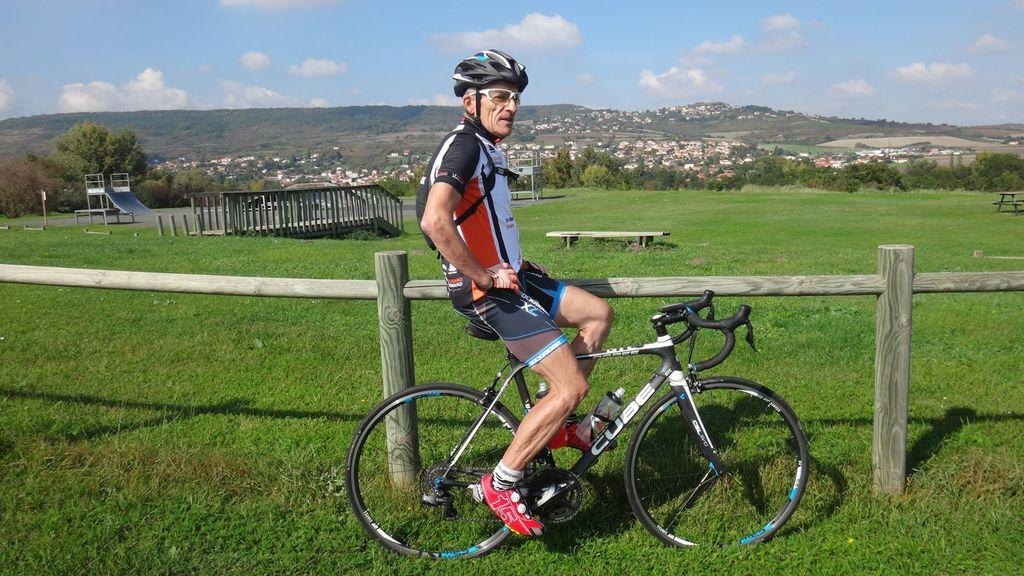What is the person in the image doing? The person is sitting on a bicycle in the image. What type of terrain is visible in the image? There is grass visible in the image. What other objects or structures can be seen in the image? There is a bench, a slide, trees, and buildings visible in the image. What type of snow can be seen on the slide in the image? There is no snow present in the image; it features grass, trees, and buildings. What songs is the person singing while sitting on the bicycle? There is no indication in the image that the person is singing any songs. 